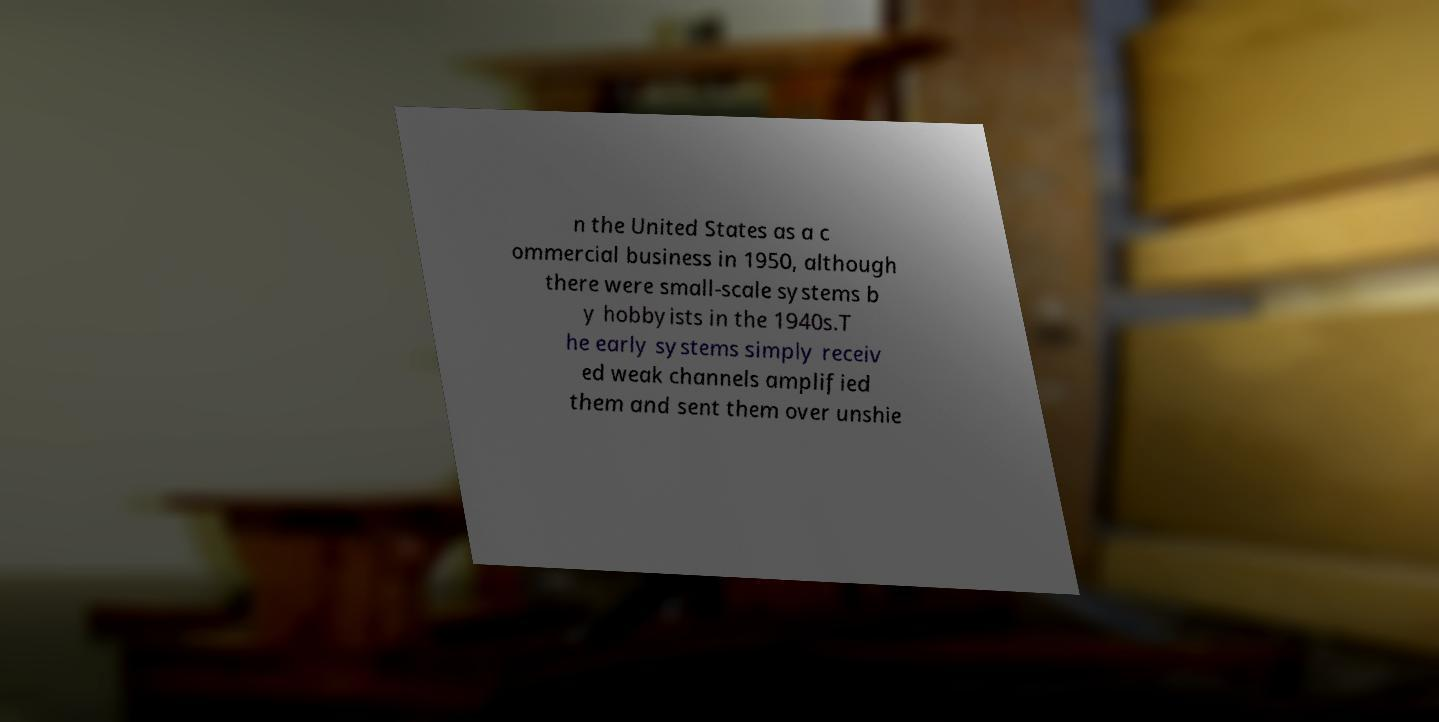Can you read and provide the text displayed in the image?This photo seems to have some interesting text. Can you extract and type it out for me? n the United States as a c ommercial business in 1950, although there were small-scale systems b y hobbyists in the 1940s.T he early systems simply receiv ed weak channels amplified them and sent them over unshie 